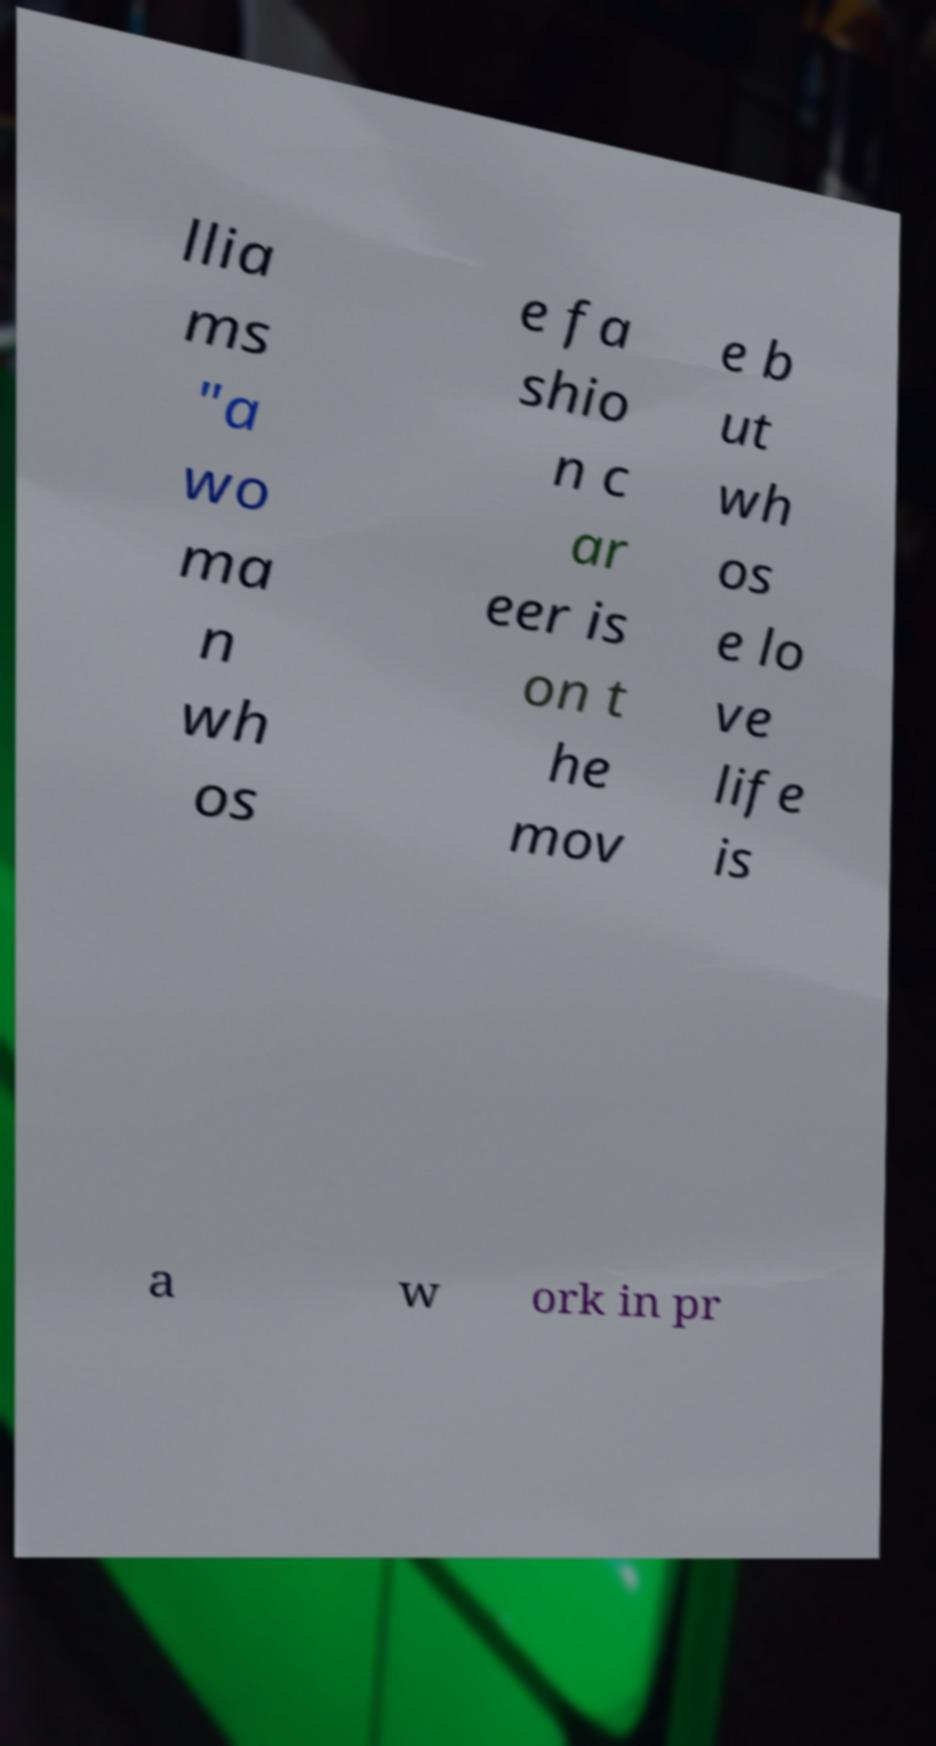Could you extract and type out the text from this image? llia ms "a wo ma n wh os e fa shio n c ar eer is on t he mov e b ut wh os e lo ve life is a w ork in pr 